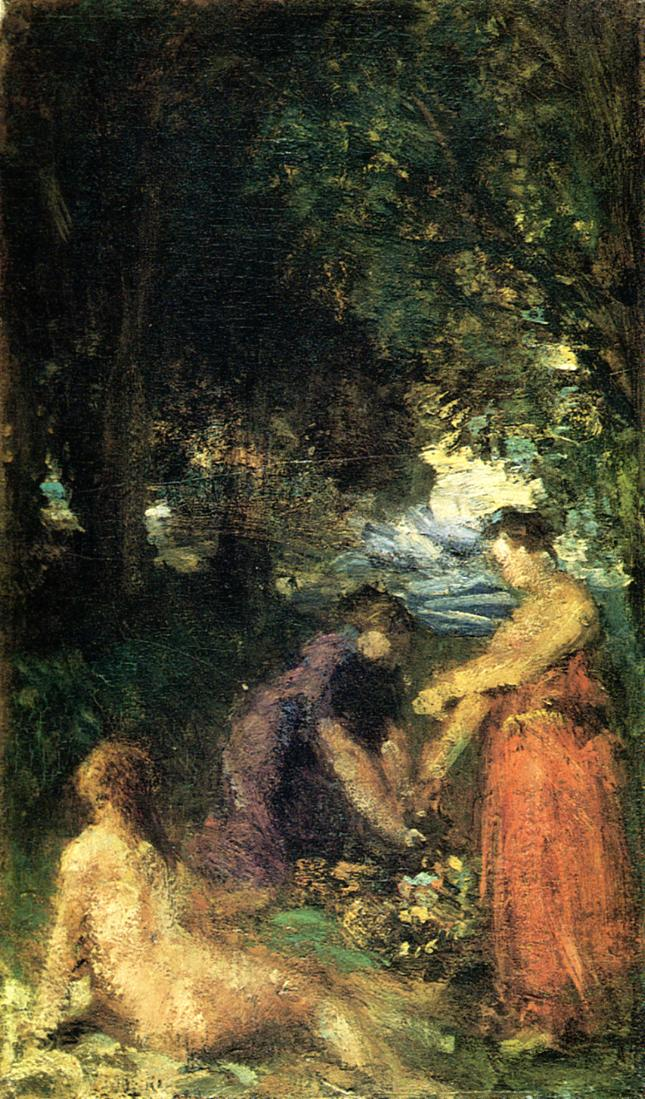Why would the artist choose such a setting for this scene? The artist may have chosen this forest setting to emphasize the tranquility and introspective nature of the moment. Forests often symbolize peace, mystery, and a place for reflection away from the distractions of everyday life. Incorporating natural elements allows the viewer to feel a deeper connection with the scene, evoking a sense of nostalgia or a longing for simpler times. Additionally, the play of light and shadow through the foliage provides a compelling visual interest and demonstrates the artist’s skill in capturing the ephemeral beauty of nature. 